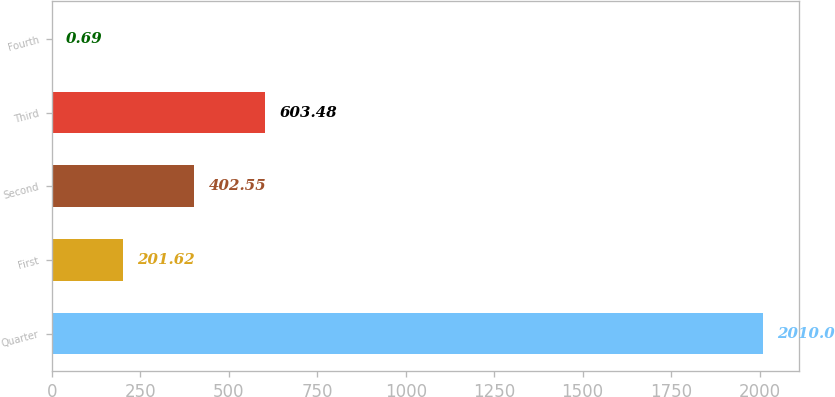Convert chart to OTSL. <chart><loc_0><loc_0><loc_500><loc_500><bar_chart><fcel>Quarter<fcel>First<fcel>Second<fcel>Third<fcel>Fourth<nl><fcel>2010<fcel>201.62<fcel>402.55<fcel>603.48<fcel>0.69<nl></chart> 